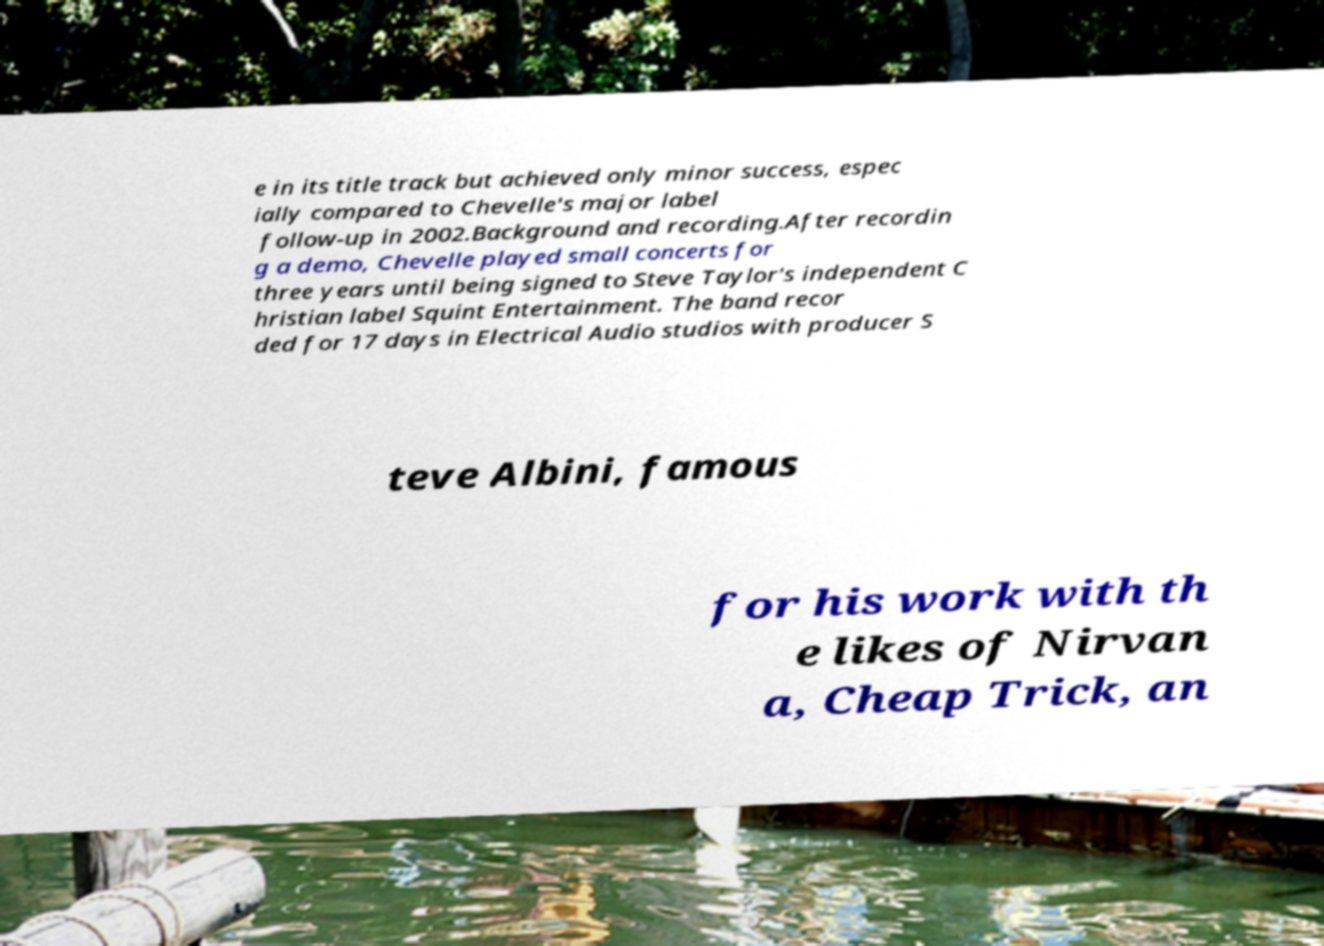I need the written content from this picture converted into text. Can you do that? e in its title track but achieved only minor success, espec ially compared to Chevelle's major label follow-up in 2002.Background and recording.After recordin g a demo, Chevelle played small concerts for three years until being signed to Steve Taylor's independent C hristian label Squint Entertainment. The band recor ded for 17 days in Electrical Audio studios with producer S teve Albini, famous for his work with th e likes of Nirvan a, Cheap Trick, an 